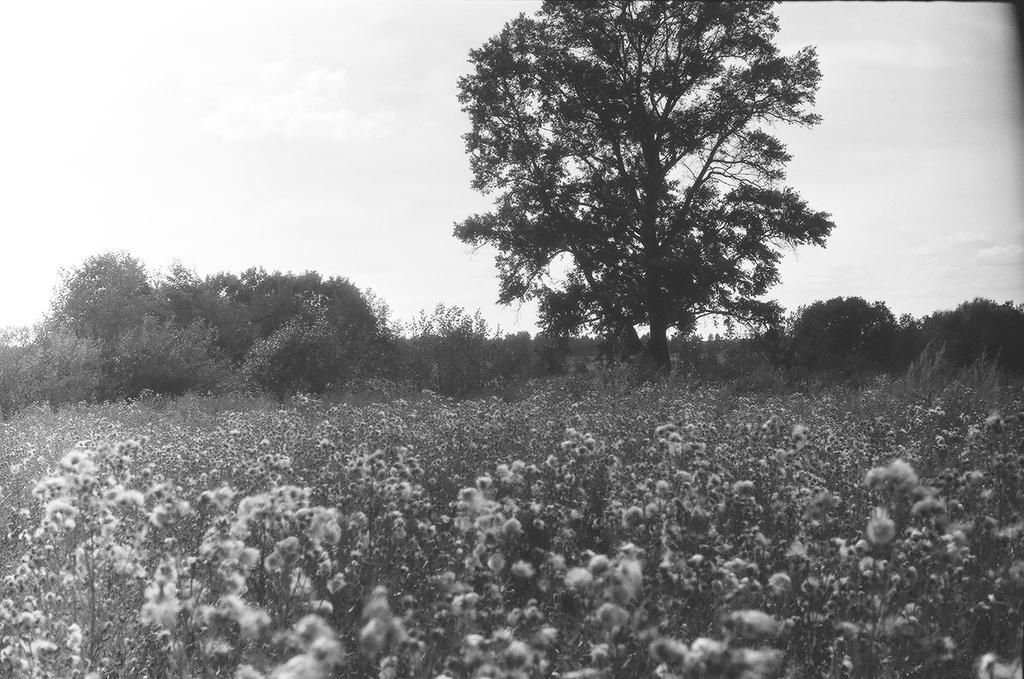What type of picture is in the image? The image contains a black and white picture. What is the main subject of the picture? The picture depicts a tree and plants. What can be seen in the background of the picture? The sky is visible in the picture. How many pies are displayed on the border of the picture? There are no pies present in the image, and the picture does not have a border. What type of respect can be seen in the image? There is no indication of respect in the image, as it only contains a black and white picture of a tree and plants. 